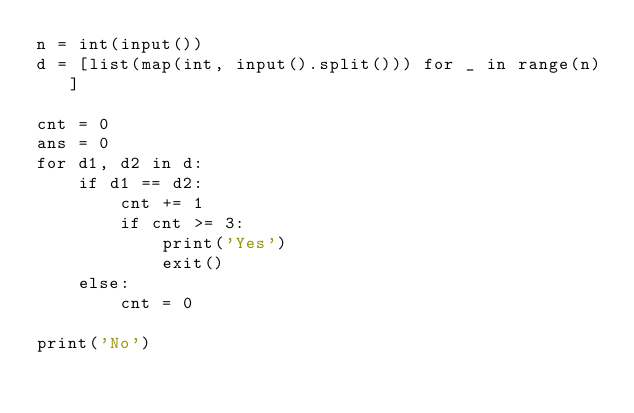<code> <loc_0><loc_0><loc_500><loc_500><_Python_>n = int(input())
d = [list(map(int, input().split())) for _ in range(n)]

cnt = 0
ans = 0
for d1, d2 in d:
    if d1 == d2:
        cnt += 1
        if cnt >= 3:
            print('Yes')
            exit()
    else:
        cnt = 0

print('No')</code> 